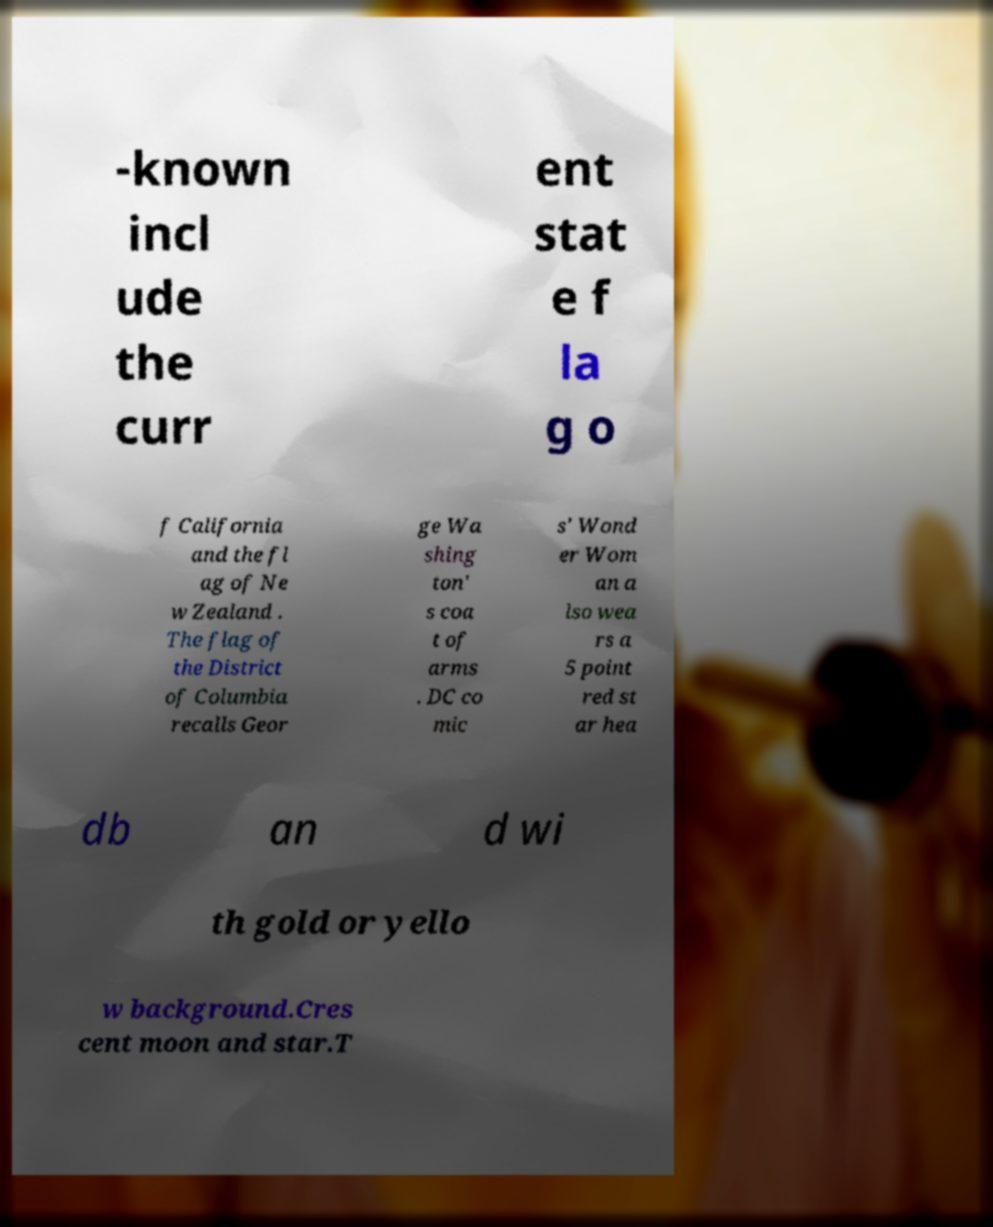What messages or text are displayed in this image? I need them in a readable, typed format. -known incl ude the curr ent stat e f la g o f California and the fl ag of Ne w Zealand . The flag of the District of Columbia recalls Geor ge Wa shing ton' s coa t of arms . DC co mic s' Wond er Wom an a lso wea rs a 5 point red st ar hea db an d wi th gold or yello w background.Cres cent moon and star.T 